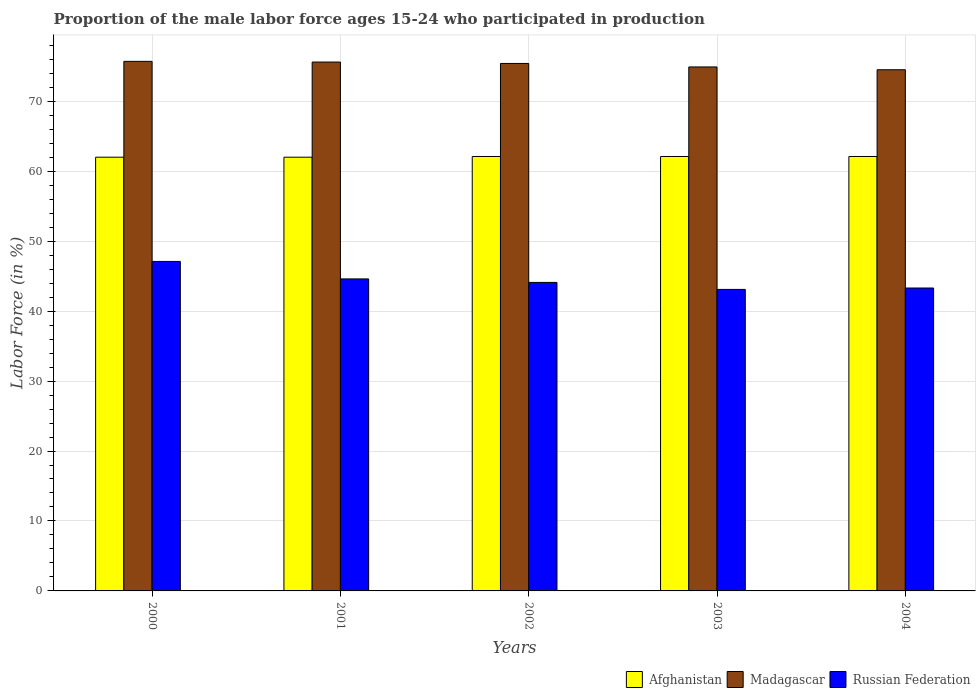How many different coloured bars are there?
Your response must be concise. 3. What is the proportion of the male labor force who participated in production in Russian Federation in 2001?
Provide a short and direct response. 44.6. Across all years, what is the maximum proportion of the male labor force who participated in production in Russian Federation?
Your response must be concise. 47.1. In which year was the proportion of the male labor force who participated in production in Russian Federation maximum?
Offer a terse response. 2000. What is the total proportion of the male labor force who participated in production in Madagascar in the graph?
Ensure brevity in your answer.  376.1. What is the difference between the proportion of the male labor force who participated in production in Russian Federation in 2001 and that in 2004?
Offer a terse response. 1.3. What is the difference between the proportion of the male labor force who participated in production in Afghanistan in 2001 and the proportion of the male labor force who participated in production in Madagascar in 2002?
Keep it short and to the point. -13.4. What is the average proportion of the male labor force who participated in production in Madagascar per year?
Your response must be concise. 75.22. In the year 2003, what is the difference between the proportion of the male labor force who participated in production in Madagascar and proportion of the male labor force who participated in production in Russian Federation?
Your response must be concise. 31.8. In how many years, is the proportion of the male labor force who participated in production in Russian Federation greater than 6 %?
Offer a terse response. 5. What is the ratio of the proportion of the male labor force who participated in production in Russian Federation in 2000 to that in 2004?
Your response must be concise. 1.09. Is the proportion of the male labor force who participated in production in Madagascar in 2002 less than that in 2003?
Your answer should be compact. No. Is the difference between the proportion of the male labor force who participated in production in Madagascar in 2003 and 2004 greater than the difference between the proportion of the male labor force who participated in production in Russian Federation in 2003 and 2004?
Your response must be concise. Yes. What is the difference between the highest and the lowest proportion of the male labor force who participated in production in Madagascar?
Make the answer very short. 1.2. In how many years, is the proportion of the male labor force who participated in production in Madagascar greater than the average proportion of the male labor force who participated in production in Madagascar taken over all years?
Your answer should be compact. 3. What does the 3rd bar from the left in 2000 represents?
Ensure brevity in your answer.  Russian Federation. What does the 2nd bar from the right in 2003 represents?
Offer a terse response. Madagascar. Is it the case that in every year, the sum of the proportion of the male labor force who participated in production in Afghanistan and proportion of the male labor force who participated in production in Russian Federation is greater than the proportion of the male labor force who participated in production in Madagascar?
Provide a short and direct response. Yes. How many bars are there?
Make the answer very short. 15. What is the difference between two consecutive major ticks on the Y-axis?
Make the answer very short. 10. Does the graph contain grids?
Make the answer very short. Yes. Where does the legend appear in the graph?
Give a very brief answer. Bottom right. How many legend labels are there?
Give a very brief answer. 3. What is the title of the graph?
Provide a short and direct response. Proportion of the male labor force ages 15-24 who participated in production. Does "Malawi" appear as one of the legend labels in the graph?
Give a very brief answer. No. What is the label or title of the Y-axis?
Give a very brief answer. Labor Force (in %). What is the Labor Force (in %) of Madagascar in 2000?
Your answer should be very brief. 75.7. What is the Labor Force (in %) of Russian Federation in 2000?
Keep it short and to the point. 47.1. What is the Labor Force (in %) in Madagascar in 2001?
Your response must be concise. 75.6. What is the Labor Force (in %) of Russian Federation in 2001?
Offer a very short reply. 44.6. What is the Labor Force (in %) in Afghanistan in 2002?
Provide a succinct answer. 62.1. What is the Labor Force (in %) in Madagascar in 2002?
Ensure brevity in your answer.  75.4. What is the Labor Force (in %) in Russian Federation in 2002?
Make the answer very short. 44.1. What is the Labor Force (in %) of Afghanistan in 2003?
Provide a succinct answer. 62.1. What is the Labor Force (in %) of Madagascar in 2003?
Your answer should be compact. 74.9. What is the Labor Force (in %) of Russian Federation in 2003?
Give a very brief answer. 43.1. What is the Labor Force (in %) of Afghanistan in 2004?
Provide a short and direct response. 62.1. What is the Labor Force (in %) of Madagascar in 2004?
Offer a very short reply. 74.5. What is the Labor Force (in %) of Russian Federation in 2004?
Your response must be concise. 43.3. Across all years, what is the maximum Labor Force (in %) of Afghanistan?
Your response must be concise. 62.1. Across all years, what is the maximum Labor Force (in %) in Madagascar?
Offer a very short reply. 75.7. Across all years, what is the maximum Labor Force (in %) in Russian Federation?
Your response must be concise. 47.1. Across all years, what is the minimum Labor Force (in %) of Afghanistan?
Keep it short and to the point. 62. Across all years, what is the minimum Labor Force (in %) in Madagascar?
Your response must be concise. 74.5. Across all years, what is the minimum Labor Force (in %) in Russian Federation?
Offer a terse response. 43.1. What is the total Labor Force (in %) of Afghanistan in the graph?
Ensure brevity in your answer.  310.3. What is the total Labor Force (in %) of Madagascar in the graph?
Your answer should be compact. 376.1. What is the total Labor Force (in %) of Russian Federation in the graph?
Keep it short and to the point. 222.2. What is the difference between the Labor Force (in %) of Afghanistan in 2000 and that in 2001?
Your response must be concise. 0. What is the difference between the Labor Force (in %) of Madagascar in 2000 and that in 2001?
Provide a succinct answer. 0.1. What is the difference between the Labor Force (in %) of Russian Federation in 2000 and that in 2001?
Keep it short and to the point. 2.5. What is the difference between the Labor Force (in %) in Afghanistan in 2000 and that in 2003?
Keep it short and to the point. -0.1. What is the difference between the Labor Force (in %) in Madagascar in 2000 and that in 2003?
Your response must be concise. 0.8. What is the difference between the Labor Force (in %) of Russian Federation in 2000 and that in 2003?
Give a very brief answer. 4. What is the difference between the Labor Force (in %) in Afghanistan in 2000 and that in 2004?
Offer a very short reply. -0.1. What is the difference between the Labor Force (in %) of Madagascar in 2000 and that in 2004?
Your response must be concise. 1.2. What is the difference between the Labor Force (in %) in Russian Federation in 2000 and that in 2004?
Give a very brief answer. 3.8. What is the difference between the Labor Force (in %) of Afghanistan in 2001 and that in 2003?
Make the answer very short. -0.1. What is the difference between the Labor Force (in %) of Madagascar in 2001 and that in 2003?
Provide a short and direct response. 0.7. What is the difference between the Labor Force (in %) in Russian Federation in 2001 and that in 2003?
Provide a short and direct response. 1.5. What is the difference between the Labor Force (in %) of Afghanistan in 2001 and that in 2004?
Offer a terse response. -0.1. What is the difference between the Labor Force (in %) in Madagascar in 2001 and that in 2004?
Provide a short and direct response. 1.1. What is the difference between the Labor Force (in %) of Russian Federation in 2001 and that in 2004?
Keep it short and to the point. 1.3. What is the difference between the Labor Force (in %) in Afghanistan in 2002 and that in 2003?
Offer a very short reply. 0. What is the difference between the Labor Force (in %) of Russian Federation in 2002 and that in 2003?
Provide a succinct answer. 1. What is the difference between the Labor Force (in %) of Madagascar in 2002 and that in 2004?
Your answer should be compact. 0.9. What is the difference between the Labor Force (in %) in Russian Federation in 2002 and that in 2004?
Your answer should be compact. 0.8. What is the difference between the Labor Force (in %) of Afghanistan in 2003 and that in 2004?
Provide a short and direct response. 0. What is the difference between the Labor Force (in %) of Russian Federation in 2003 and that in 2004?
Offer a terse response. -0.2. What is the difference between the Labor Force (in %) of Afghanistan in 2000 and the Labor Force (in %) of Madagascar in 2001?
Your answer should be compact. -13.6. What is the difference between the Labor Force (in %) in Afghanistan in 2000 and the Labor Force (in %) in Russian Federation in 2001?
Keep it short and to the point. 17.4. What is the difference between the Labor Force (in %) of Madagascar in 2000 and the Labor Force (in %) of Russian Federation in 2001?
Your response must be concise. 31.1. What is the difference between the Labor Force (in %) in Afghanistan in 2000 and the Labor Force (in %) in Madagascar in 2002?
Make the answer very short. -13.4. What is the difference between the Labor Force (in %) in Afghanistan in 2000 and the Labor Force (in %) in Russian Federation in 2002?
Ensure brevity in your answer.  17.9. What is the difference between the Labor Force (in %) of Madagascar in 2000 and the Labor Force (in %) of Russian Federation in 2002?
Offer a very short reply. 31.6. What is the difference between the Labor Force (in %) in Afghanistan in 2000 and the Labor Force (in %) in Madagascar in 2003?
Provide a succinct answer. -12.9. What is the difference between the Labor Force (in %) in Afghanistan in 2000 and the Labor Force (in %) in Russian Federation in 2003?
Keep it short and to the point. 18.9. What is the difference between the Labor Force (in %) in Madagascar in 2000 and the Labor Force (in %) in Russian Federation in 2003?
Give a very brief answer. 32.6. What is the difference between the Labor Force (in %) of Afghanistan in 2000 and the Labor Force (in %) of Madagascar in 2004?
Offer a very short reply. -12.5. What is the difference between the Labor Force (in %) in Madagascar in 2000 and the Labor Force (in %) in Russian Federation in 2004?
Provide a succinct answer. 32.4. What is the difference between the Labor Force (in %) in Afghanistan in 2001 and the Labor Force (in %) in Russian Federation in 2002?
Give a very brief answer. 17.9. What is the difference between the Labor Force (in %) in Madagascar in 2001 and the Labor Force (in %) in Russian Federation in 2002?
Provide a succinct answer. 31.5. What is the difference between the Labor Force (in %) in Afghanistan in 2001 and the Labor Force (in %) in Madagascar in 2003?
Your answer should be very brief. -12.9. What is the difference between the Labor Force (in %) of Madagascar in 2001 and the Labor Force (in %) of Russian Federation in 2003?
Provide a short and direct response. 32.5. What is the difference between the Labor Force (in %) of Madagascar in 2001 and the Labor Force (in %) of Russian Federation in 2004?
Keep it short and to the point. 32.3. What is the difference between the Labor Force (in %) in Afghanistan in 2002 and the Labor Force (in %) in Russian Federation in 2003?
Offer a terse response. 19. What is the difference between the Labor Force (in %) in Madagascar in 2002 and the Labor Force (in %) in Russian Federation in 2003?
Give a very brief answer. 32.3. What is the difference between the Labor Force (in %) in Afghanistan in 2002 and the Labor Force (in %) in Russian Federation in 2004?
Offer a very short reply. 18.8. What is the difference between the Labor Force (in %) in Madagascar in 2002 and the Labor Force (in %) in Russian Federation in 2004?
Keep it short and to the point. 32.1. What is the difference between the Labor Force (in %) in Madagascar in 2003 and the Labor Force (in %) in Russian Federation in 2004?
Offer a very short reply. 31.6. What is the average Labor Force (in %) in Afghanistan per year?
Make the answer very short. 62.06. What is the average Labor Force (in %) in Madagascar per year?
Give a very brief answer. 75.22. What is the average Labor Force (in %) in Russian Federation per year?
Give a very brief answer. 44.44. In the year 2000, what is the difference between the Labor Force (in %) of Afghanistan and Labor Force (in %) of Madagascar?
Your response must be concise. -13.7. In the year 2000, what is the difference between the Labor Force (in %) of Madagascar and Labor Force (in %) of Russian Federation?
Keep it short and to the point. 28.6. In the year 2001, what is the difference between the Labor Force (in %) in Afghanistan and Labor Force (in %) in Russian Federation?
Provide a short and direct response. 17.4. In the year 2002, what is the difference between the Labor Force (in %) of Madagascar and Labor Force (in %) of Russian Federation?
Your answer should be compact. 31.3. In the year 2003, what is the difference between the Labor Force (in %) of Afghanistan and Labor Force (in %) of Madagascar?
Keep it short and to the point. -12.8. In the year 2003, what is the difference between the Labor Force (in %) of Madagascar and Labor Force (in %) of Russian Federation?
Keep it short and to the point. 31.8. In the year 2004, what is the difference between the Labor Force (in %) of Madagascar and Labor Force (in %) of Russian Federation?
Your answer should be compact. 31.2. What is the ratio of the Labor Force (in %) of Madagascar in 2000 to that in 2001?
Your answer should be very brief. 1. What is the ratio of the Labor Force (in %) in Russian Federation in 2000 to that in 2001?
Your answer should be compact. 1.06. What is the ratio of the Labor Force (in %) of Afghanistan in 2000 to that in 2002?
Ensure brevity in your answer.  1. What is the ratio of the Labor Force (in %) of Madagascar in 2000 to that in 2002?
Provide a succinct answer. 1. What is the ratio of the Labor Force (in %) in Russian Federation in 2000 to that in 2002?
Your answer should be very brief. 1.07. What is the ratio of the Labor Force (in %) in Madagascar in 2000 to that in 2003?
Provide a succinct answer. 1.01. What is the ratio of the Labor Force (in %) of Russian Federation in 2000 to that in 2003?
Offer a very short reply. 1.09. What is the ratio of the Labor Force (in %) in Afghanistan in 2000 to that in 2004?
Provide a short and direct response. 1. What is the ratio of the Labor Force (in %) of Madagascar in 2000 to that in 2004?
Offer a very short reply. 1.02. What is the ratio of the Labor Force (in %) in Russian Federation in 2000 to that in 2004?
Provide a succinct answer. 1.09. What is the ratio of the Labor Force (in %) of Madagascar in 2001 to that in 2002?
Give a very brief answer. 1. What is the ratio of the Labor Force (in %) of Russian Federation in 2001 to that in 2002?
Your answer should be compact. 1.01. What is the ratio of the Labor Force (in %) in Madagascar in 2001 to that in 2003?
Offer a very short reply. 1.01. What is the ratio of the Labor Force (in %) in Russian Federation in 2001 to that in 2003?
Provide a short and direct response. 1.03. What is the ratio of the Labor Force (in %) in Afghanistan in 2001 to that in 2004?
Give a very brief answer. 1. What is the ratio of the Labor Force (in %) in Madagascar in 2001 to that in 2004?
Provide a short and direct response. 1.01. What is the ratio of the Labor Force (in %) in Madagascar in 2002 to that in 2003?
Offer a terse response. 1.01. What is the ratio of the Labor Force (in %) in Russian Federation in 2002 to that in 2003?
Your response must be concise. 1.02. What is the ratio of the Labor Force (in %) in Afghanistan in 2002 to that in 2004?
Your answer should be very brief. 1. What is the ratio of the Labor Force (in %) of Madagascar in 2002 to that in 2004?
Make the answer very short. 1.01. What is the ratio of the Labor Force (in %) of Russian Federation in 2002 to that in 2004?
Ensure brevity in your answer.  1.02. What is the ratio of the Labor Force (in %) in Madagascar in 2003 to that in 2004?
Keep it short and to the point. 1.01. What is the difference between the highest and the second highest Labor Force (in %) of Afghanistan?
Provide a succinct answer. 0. What is the difference between the highest and the second highest Labor Force (in %) in Madagascar?
Give a very brief answer. 0.1. What is the difference between the highest and the second highest Labor Force (in %) in Russian Federation?
Make the answer very short. 2.5. What is the difference between the highest and the lowest Labor Force (in %) in Afghanistan?
Offer a terse response. 0.1. What is the difference between the highest and the lowest Labor Force (in %) in Russian Federation?
Your response must be concise. 4. 